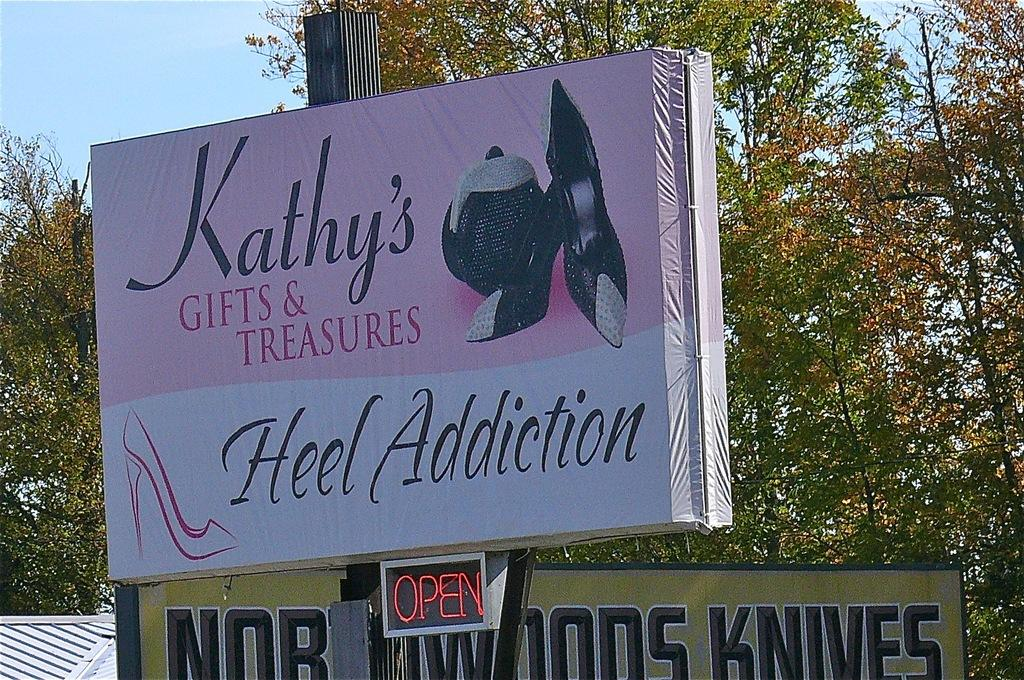Provide a one-sentence caption for the provided image. the words heel addiction that are on a sign. 